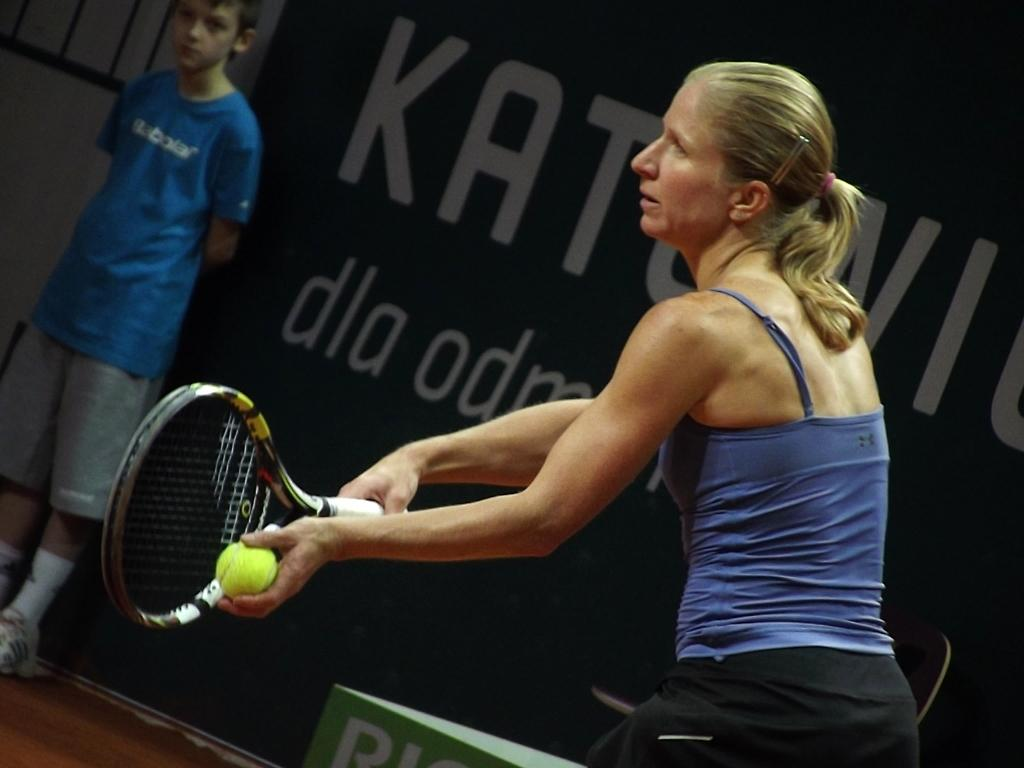How many people are in the image? There are two persons standing in the image. What are the people holding in their hands? One person is holding a bat, and the other person is holding a ball. What can be seen in the background of the image? There is a banner visible in the background of the image. What type of oatmeal is being served in the image? There is no oatmeal present in the image. How much debt is visible in the image? There is no reference to debt in the image. 